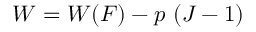Convert formula to latex. <formula><loc_0><loc_0><loc_500><loc_500>W = W ( { F } ) - p ( J - 1 )</formula> 